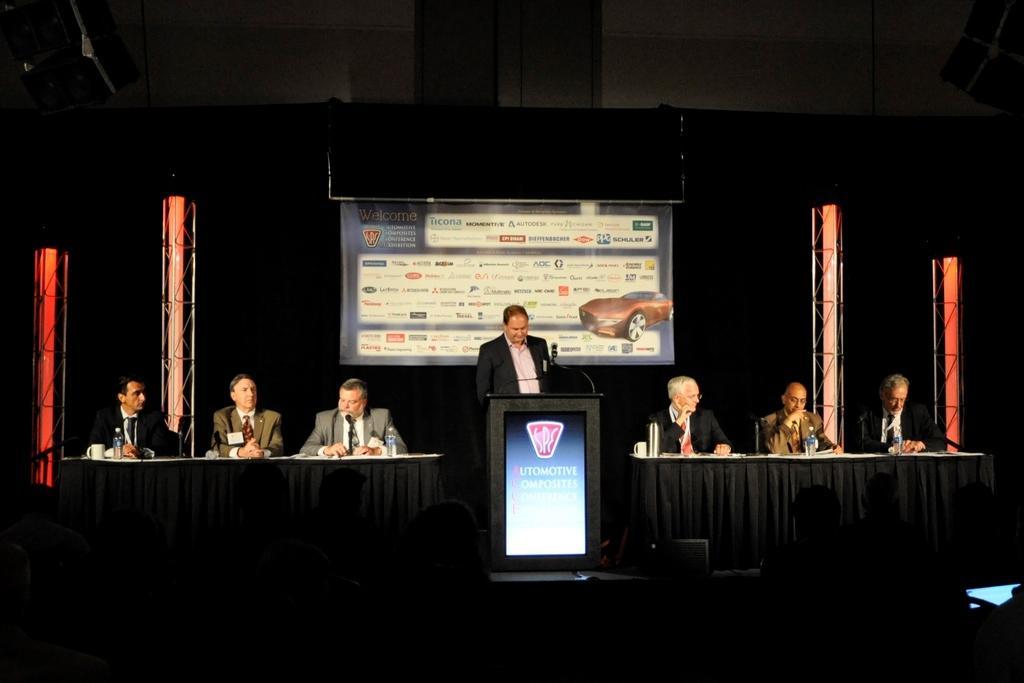Describe this image in one or two sentences. In this picture there is a man who is standing in the center of the image in front of a mic and a desk and there are other people those who are sitting on the right and left side of the image and there is a poster and pillars in the background area of the image and there are people at the bottom side of the image. 